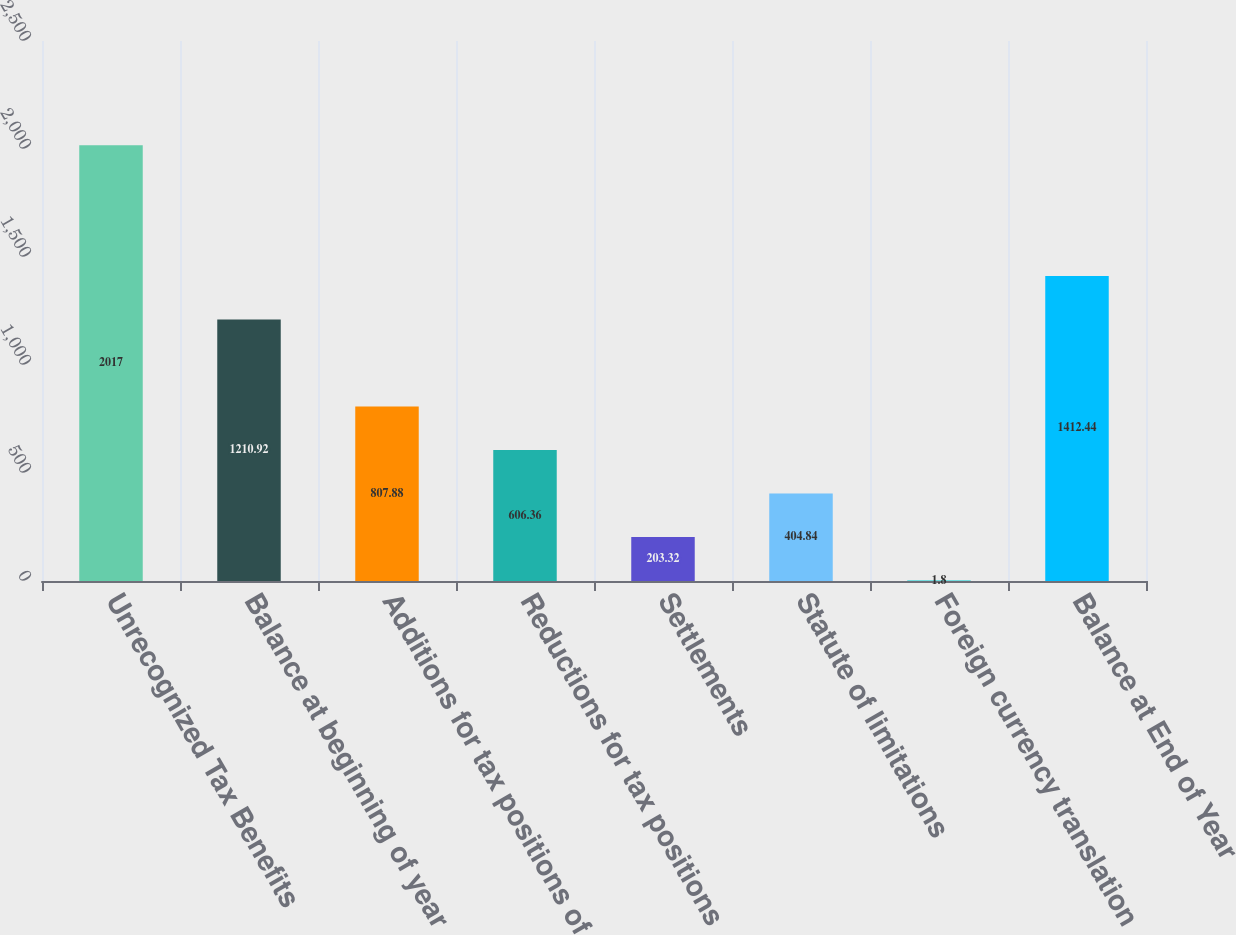<chart> <loc_0><loc_0><loc_500><loc_500><bar_chart><fcel>Unrecognized Tax Benefits<fcel>Balance at beginning of year<fcel>Additions for tax positions of<fcel>Reductions for tax positions<fcel>Settlements<fcel>Statute of limitations<fcel>Foreign currency translation<fcel>Balance at End of Year<nl><fcel>2017<fcel>1210.92<fcel>807.88<fcel>606.36<fcel>203.32<fcel>404.84<fcel>1.8<fcel>1412.44<nl></chart> 